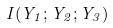Convert formula to latex. <formula><loc_0><loc_0><loc_500><loc_500>I ( Y _ { 1 } ; Y _ { 2 } ; Y _ { 3 } )</formula> 